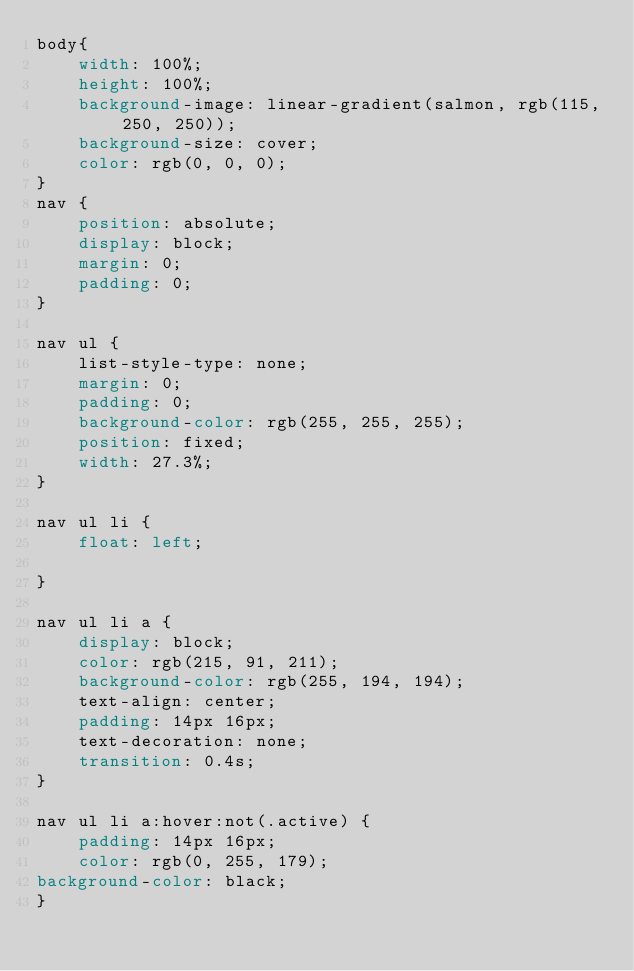Convert code to text. <code><loc_0><loc_0><loc_500><loc_500><_CSS_>body{
    width: 100%;
    height: 100%;
    background-image: linear-gradient(salmon, rgb(115, 250, 250));
    background-size: cover;
    color: rgb(0, 0, 0);
}
nav {
    position: absolute;
    display: block;
    margin: 0;
    padding: 0;
}

nav ul {
    list-style-type: none;
    margin: 0;
    padding: 0;
    background-color: rgb(255, 255, 255);
    position: fixed;
    width: 27.3%;
}

nav ul li {
    float: left;

}

nav ul li a {
    display: block;
    color: rgb(215, 91, 211);
    background-color: rgb(255, 194, 194);
    text-align: center;
    padding: 14px 16px;
    text-decoration: none;
    transition: 0.4s;
}

nav ul li a:hover:not(.active) {
    padding: 14px 16px;
    color: rgb(0, 255, 179);
background-color: black;
}</code> 